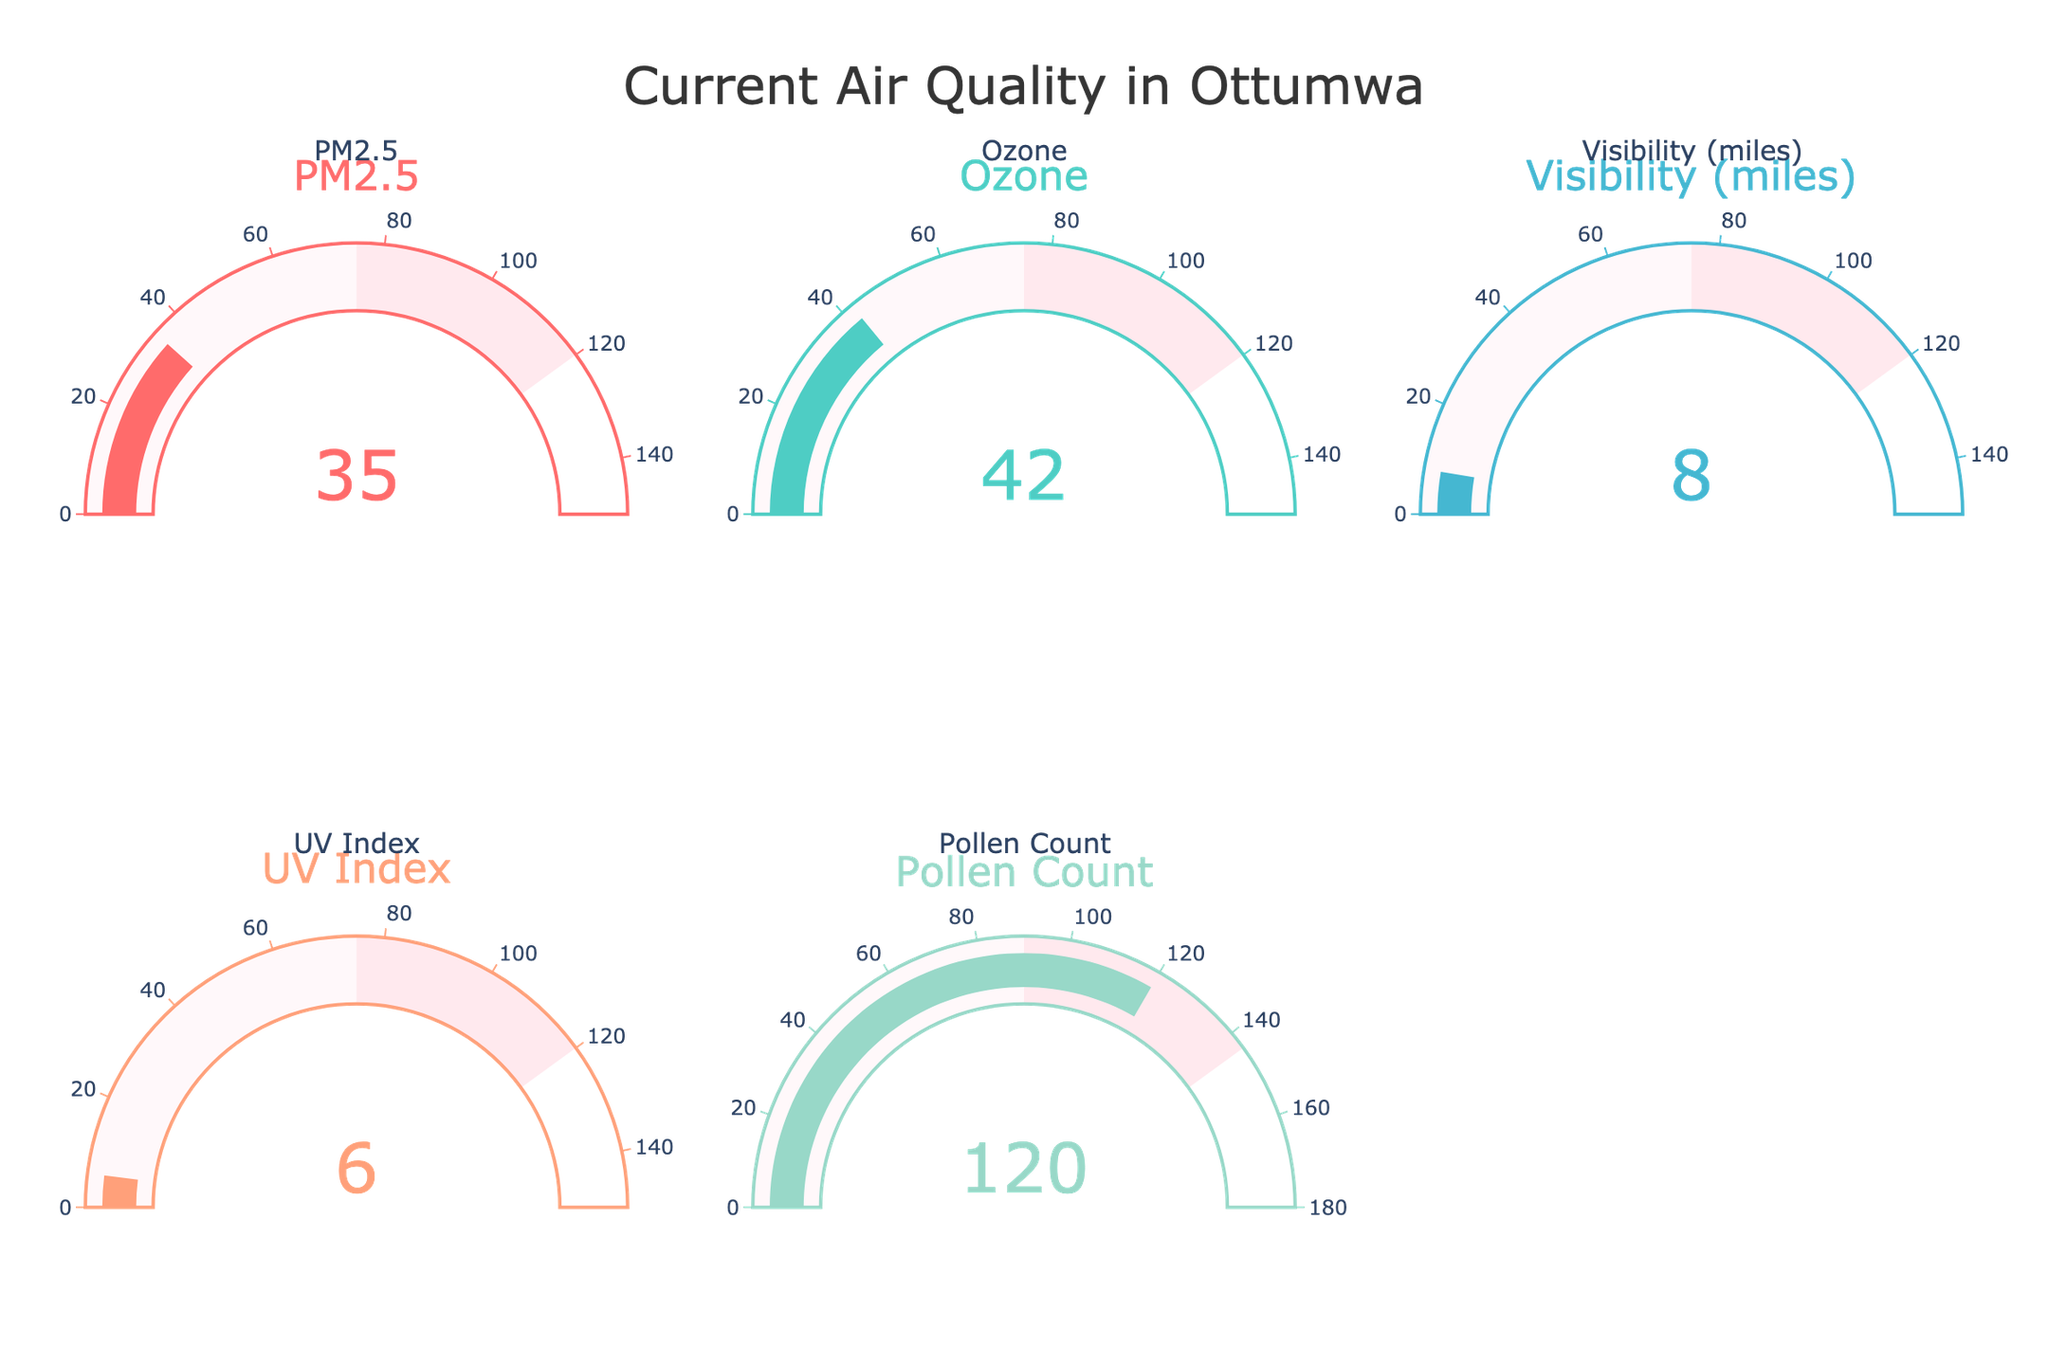What's the value displayed for the PM2.5 gauge? The PM2.5 gauge shows the value "35" in the center of the gauge.
Answer: 35 Which gauge displays the highest value? To find the highest value, compare all the values shown in the gauges: PM2.5 (35), Ozone (42), Visibility (8), UV Index (6), Pollen Count (120). The highest value is 120 for the Pollen Count.
Answer: Pollen Count How does the UV Index compare to the Ozone value? The UV Index gauge displays "6", and the Ozone gauge shows "42". Therefore, the Ozone value is significantly higher than the UV Index value.
Answer: Ozone is higher What is the average value of all the gauges? Add up the values of all the gauges: PM2.5 (35), Ozone (42), Visibility (8), UV Index (6), Pollen Count (120). The total is 211. Divide by the number of gauges (5): 211/5 = 42.2.
Answer: 42.2 Among PM2.5, Ozone, and Visibility, which has the lowest value? Comparing PM2.5 (35), Ozone (42), and Visibility (8), the lowest value is 8 for Visibility.
Answer: Visibility Which air quality measure listed might indicate the best conditions for outdoor shooting visibility? Visibility directly impacts shooting conditions, and it shows "8" miles. Higher visibility indicates better conditions for outdoor shooting.
Answer: Visibility Summarize the air quality metrics by listing them in descending order. List the values from highest to lowest: Pollen Count (120), Ozone (42), PM2.5 (35), Visibility (8), UV Index (6).
Answer: Pollen Count, Ozone, PM2.5, Visibility, UV Index What is the difference between the highest and lowest values shown on the gauges? The highest value is 120 (Pollen Count), and the lowest is 6 (UV Index). The difference is 120 - 6 = 114.
Answer: 114 